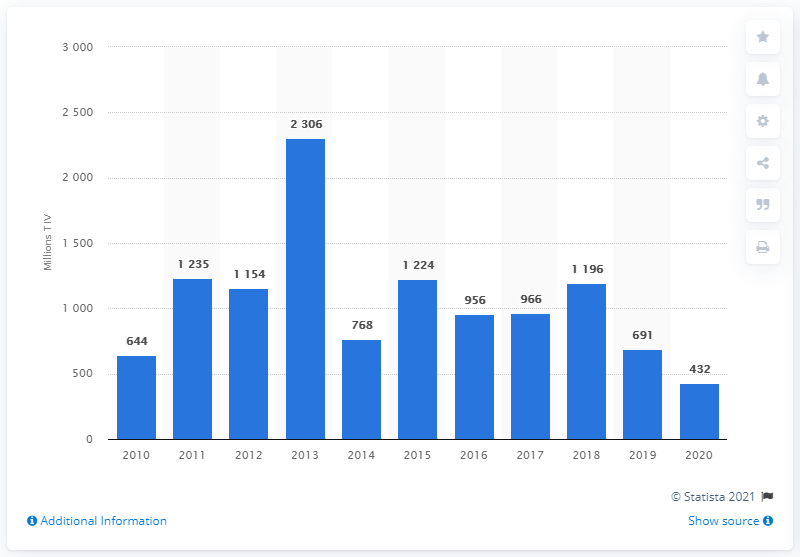Mention a couple of crucial points in this snapshot. The value of arms imports to the United Arab Emirates in 2020 was $432 million. 